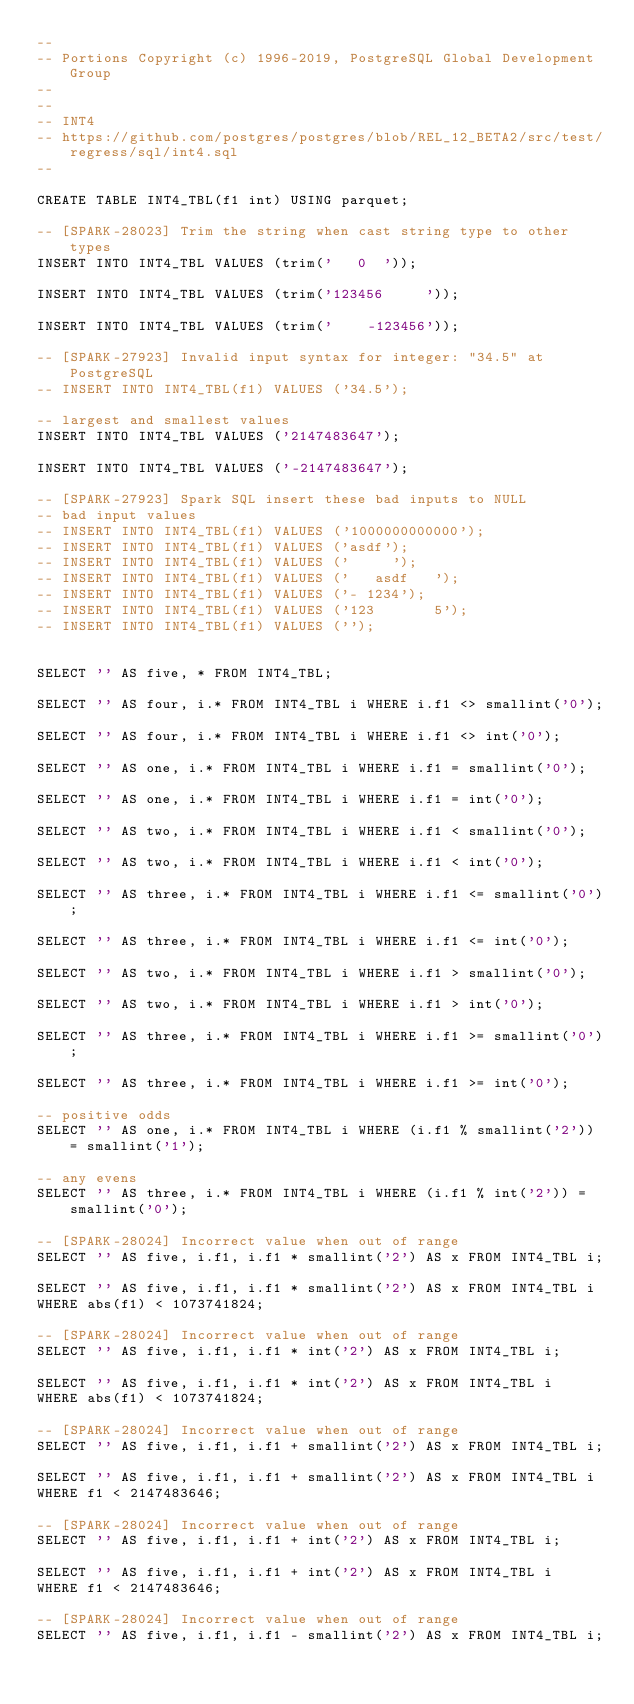<code> <loc_0><loc_0><loc_500><loc_500><_SQL_>--
-- Portions Copyright (c) 1996-2019, PostgreSQL Global Development Group
--
--
-- INT4
-- https://github.com/postgres/postgres/blob/REL_12_BETA2/src/test/regress/sql/int4.sql
--

CREATE TABLE INT4_TBL(f1 int) USING parquet;

-- [SPARK-28023] Trim the string when cast string type to other types
INSERT INTO INT4_TBL VALUES (trim('   0  '));

INSERT INTO INT4_TBL VALUES (trim('123456     '));

INSERT INTO INT4_TBL VALUES (trim('    -123456'));

-- [SPARK-27923] Invalid input syntax for integer: "34.5" at PostgreSQL
-- INSERT INTO INT4_TBL(f1) VALUES ('34.5');

-- largest and smallest values
INSERT INTO INT4_TBL VALUES ('2147483647');

INSERT INTO INT4_TBL VALUES ('-2147483647');

-- [SPARK-27923] Spark SQL insert these bad inputs to NULL
-- bad input values
-- INSERT INTO INT4_TBL(f1) VALUES ('1000000000000');
-- INSERT INTO INT4_TBL(f1) VALUES ('asdf');
-- INSERT INTO INT4_TBL(f1) VALUES ('     ');
-- INSERT INTO INT4_TBL(f1) VALUES ('   asdf   ');
-- INSERT INTO INT4_TBL(f1) VALUES ('- 1234');
-- INSERT INTO INT4_TBL(f1) VALUES ('123       5');
-- INSERT INTO INT4_TBL(f1) VALUES ('');


SELECT '' AS five, * FROM INT4_TBL;

SELECT '' AS four, i.* FROM INT4_TBL i WHERE i.f1 <> smallint('0');

SELECT '' AS four, i.* FROM INT4_TBL i WHERE i.f1 <> int('0');

SELECT '' AS one, i.* FROM INT4_TBL i WHERE i.f1 = smallint('0');

SELECT '' AS one, i.* FROM INT4_TBL i WHERE i.f1 = int('0');

SELECT '' AS two, i.* FROM INT4_TBL i WHERE i.f1 < smallint('0');

SELECT '' AS two, i.* FROM INT4_TBL i WHERE i.f1 < int('0');

SELECT '' AS three, i.* FROM INT4_TBL i WHERE i.f1 <= smallint('0');

SELECT '' AS three, i.* FROM INT4_TBL i WHERE i.f1 <= int('0');

SELECT '' AS two, i.* FROM INT4_TBL i WHERE i.f1 > smallint('0');

SELECT '' AS two, i.* FROM INT4_TBL i WHERE i.f1 > int('0');

SELECT '' AS three, i.* FROM INT4_TBL i WHERE i.f1 >= smallint('0');

SELECT '' AS three, i.* FROM INT4_TBL i WHERE i.f1 >= int('0');

-- positive odds
SELECT '' AS one, i.* FROM INT4_TBL i WHERE (i.f1 % smallint('2')) = smallint('1');

-- any evens
SELECT '' AS three, i.* FROM INT4_TBL i WHERE (i.f1 % int('2')) = smallint('0');

-- [SPARK-28024] Incorrect value when out of range
SELECT '' AS five, i.f1, i.f1 * smallint('2') AS x FROM INT4_TBL i;

SELECT '' AS five, i.f1, i.f1 * smallint('2') AS x FROM INT4_TBL i
WHERE abs(f1) < 1073741824;

-- [SPARK-28024] Incorrect value when out of range
SELECT '' AS five, i.f1, i.f1 * int('2') AS x FROM INT4_TBL i;

SELECT '' AS five, i.f1, i.f1 * int('2') AS x FROM INT4_TBL i
WHERE abs(f1) < 1073741824;

-- [SPARK-28024] Incorrect value when out of range
SELECT '' AS five, i.f1, i.f1 + smallint('2') AS x FROM INT4_TBL i;

SELECT '' AS five, i.f1, i.f1 + smallint('2') AS x FROM INT4_TBL i
WHERE f1 < 2147483646;

-- [SPARK-28024] Incorrect value when out of range
SELECT '' AS five, i.f1, i.f1 + int('2') AS x FROM INT4_TBL i;

SELECT '' AS five, i.f1, i.f1 + int('2') AS x FROM INT4_TBL i
WHERE f1 < 2147483646;

-- [SPARK-28024] Incorrect value when out of range
SELECT '' AS five, i.f1, i.f1 - smallint('2') AS x FROM INT4_TBL i;
</code> 